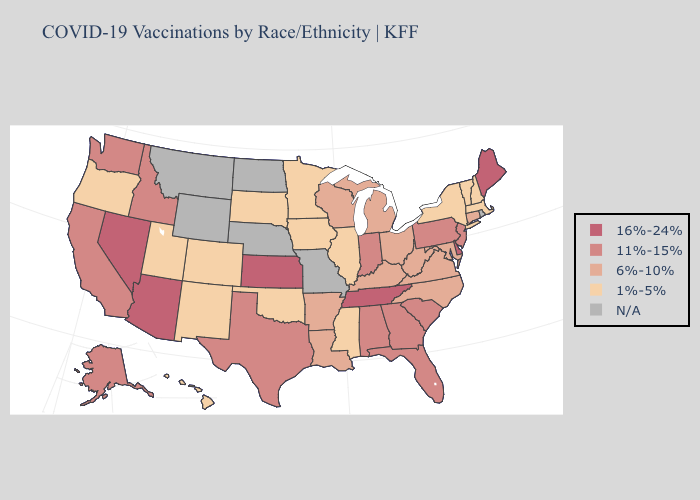How many symbols are there in the legend?
Answer briefly. 5. Which states have the lowest value in the South?
Be succinct. Mississippi, Oklahoma. What is the highest value in states that border Mississippi?
Be succinct. 16%-24%. Does Tennessee have the highest value in the South?
Answer briefly. Yes. Among the states that border South Carolina , does North Carolina have the highest value?
Short answer required. No. What is the value of New Mexico?
Quick response, please. 1%-5%. What is the lowest value in the USA?
Concise answer only. 1%-5%. Does Illinois have the highest value in the MidWest?
Short answer required. No. What is the highest value in the USA?
Short answer required. 16%-24%. Which states have the lowest value in the USA?
Concise answer only. Colorado, Hawaii, Illinois, Iowa, Massachusetts, Minnesota, Mississippi, New Hampshire, New Mexico, New York, Oklahoma, Oregon, South Dakota, Utah, Vermont. Name the states that have a value in the range 11%-15%?
Be succinct. Alabama, Alaska, California, Florida, Georgia, Idaho, Indiana, New Jersey, Pennsylvania, South Carolina, Texas, Washington. Name the states that have a value in the range 6%-10%?
Concise answer only. Arkansas, Connecticut, Kentucky, Louisiana, Maryland, Michigan, North Carolina, Ohio, Virginia, West Virginia, Wisconsin. Is the legend a continuous bar?
Keep it brief. No. Name the states that have a value in the range 6%-10%?
Answer briefly. Arkansas, Connecticut, Kentucky, Louisiana, Maryland, Michigan, North Carolina, Ohio, Virginia, West Virginia, Wisconsin. 